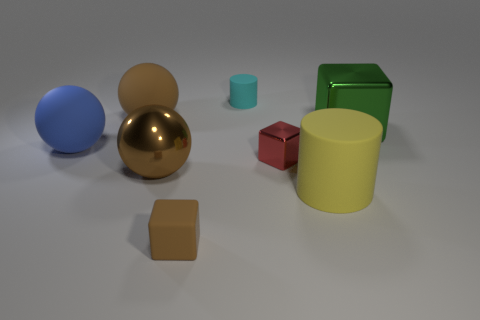Add 1 red metal objects. How many objects exist? 9 Subtract all cylinders. How many objects are left? 6 Subtract 0 yellow blocks. How many objects are left? 8 Subtract all tiny blue metallic objects. Subtract all small brown cubes. How many objects are left? 7 Add 3 big yellow matte things. How many big yellow matte things are left? 4 Add 2 big gray rubber cubes. How many big gray rubber cubes exist? 2 